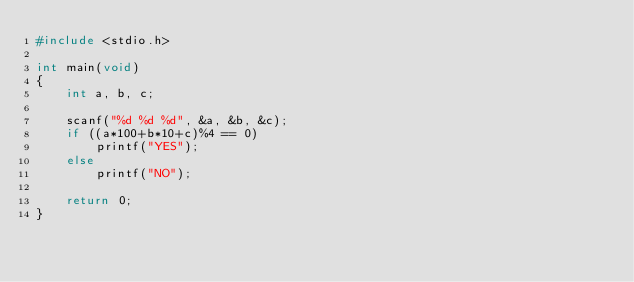Convert code to text. <code><loc_0><loc_0><loc_500><loc_500><_C_>#include <stdio.h>

int main(void)
{
    int a, b, c;

    scanf("%d %d %d", &a, &b, &c);
    if ((a*100+b*10+c)%4 == 0)
        printf("YES");
    else
        printf("NO");

    return 0;
}</code> 